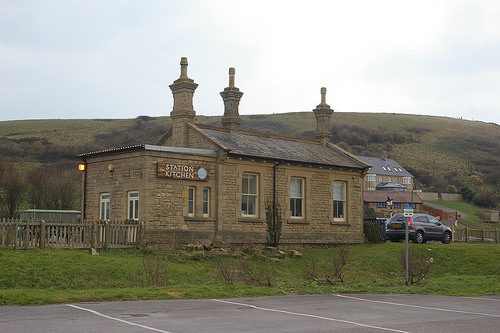<image>
Is the sign above the window? No. The sign is not positioned above the window. The vertical arrangement shows a different relationship. Where is the car in relation to the building? Is it to the right of the building? Yes. From this viewpoint, the car is positioned to the right side relative to the building. 